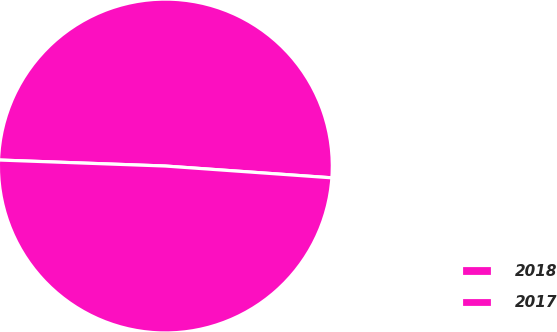Convert chart. <chart><loc_0><loc_0><loc_500><loc_500><pie_chart><fcel>2018<fcel>2017<nl><fcel>50.55%<fcel>49.45%<nl></chart> 